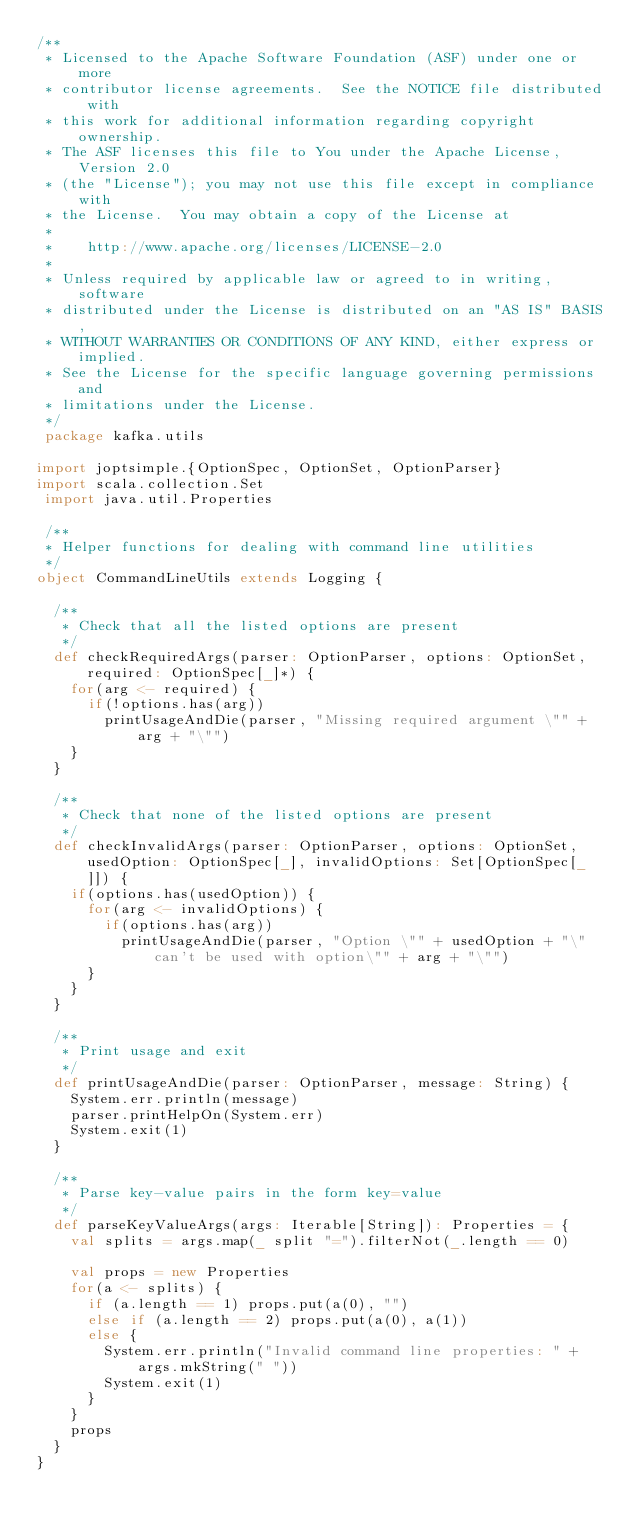<code> <loc_0><loc_0><loc_500><loc_500><_Scala_>/**
 * Licensed to the Apache Software Foundation (ASF) under one or more
 * contributor license agreements.  See the NOTICE file distributed with
 * this work for additional information regarding copyright ownership.
 * The ASF licenses this file to You under the Apache License, Version 2.0
 * (the "License"); you may not use this file except in compliance with
 * the License.  You may obtain a copy of the License at
 * 
 *    http://www.apache.org/licenses/LICENSE-2.0
 *
 * Unless required by applicable law or agreed to in writing, software
 * distributed under the License is distributed on an "AS IS" BASIS,
 * WITHOUT WARRANTIES OR CONDITIONS OF ANY KIND, either express or implied.
 * See the License for the specific language governing permissions and
 * limitations under the License.
 */
 package kafka.utils

import joptsimple.{OptionSpec, OptionSet, OptionParser}
import scala.collection.Set
 import java.util.Properties

 /**
 * Helper functions for dealing with command line utilities
 */
object CommandLineUtils extends Logging {

  /**
   * Check that all the listed options are present
   */
  def checkRequiredArgs(parser: OptionParser, options: OptionSet, required: OptionSpec[_]*) {
    for(arg <- required) {
      if(!options.has(arg))
        printUsageAndDie(parser, "Missing required argument \"" + arg + "\"")
    }
  }
  
  /**
   * Check that none of the listed options are present
   */
  def checkInvalidArgs(parser: OptionParser, options: OptionSet, usedOption: OptionSpec[_], invalidOptions: Set[OptionSpec[_]]) {
    if(options.has(usedOption)) {
      for(arg <- invalidOptions) {
        if(options.has(arg))
          printUsageAndDie(parser, "Option \"" + usedOption + "\" can't be used with option\"" + arg + "\"")
      }
    }
  }
  
  /**
   * Print usage and exit
   */
  def printUsageAndDie(parser: OptionParser, message: String) {
    System.err.println(message)
    parser.printHelpOn(System.err)
    System.exit(1)
  }

  /**
   * Parse key-value pairs in the form key=value
   */
  def parseKeyValueArgs(args: Iterable[String]): Properties = {
    val splits = args.map(_ split "=").filterNot(_.length == 0)

    val props = new Properties
    for(a <- splits) {
      if (a.length == 1) props.put(a(0), "")
      else if (a.length == 2) props.put(a(0), a(1))
      else {
        System.err.println("Invalid command line properties: " + args.mkString(" "))
        System.exit(1)
      }
    }
    props
  }
}</code> 